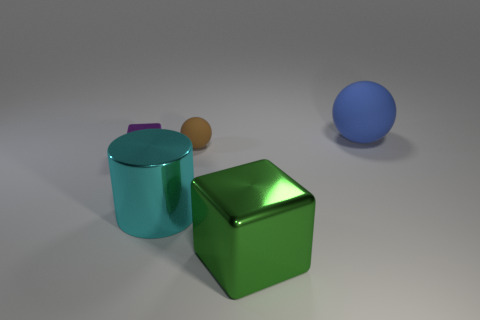Add 5 tiny brown blocks. How many objects exist? 10 Subtract all blocks. How many objects are left? 3 Subtract all shiny cylinders. Subtract all small brown rubber objects. How many objects are left? 3 Add 1 big blue things. How many big blue things are left? 2 Add 2 red shiny balls. How many red shiny balls exist? 2 Subtract 0 brown cylinders. How many objects are left? 5 